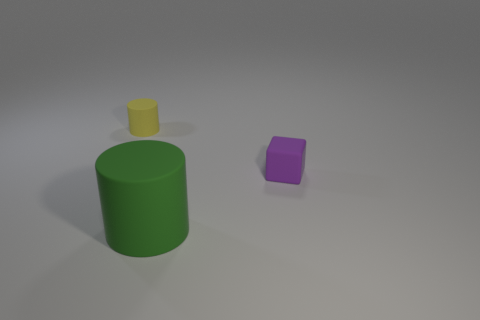Add 2 purple rubber objects. How many objects exist? 5 Subtract all blocks. How many objects are left? 2 Add 2 small yellow rubber objects. How many small yellow rubber objects are left? 3 Add 1 gray cylinders. How many gray cylinders exist? 1 Subtract 0 yellow balls. How many objects are left? 3 Subtract all yellow things. Subtract all tiny yellow matte cylinders. How many objects are left? 1 